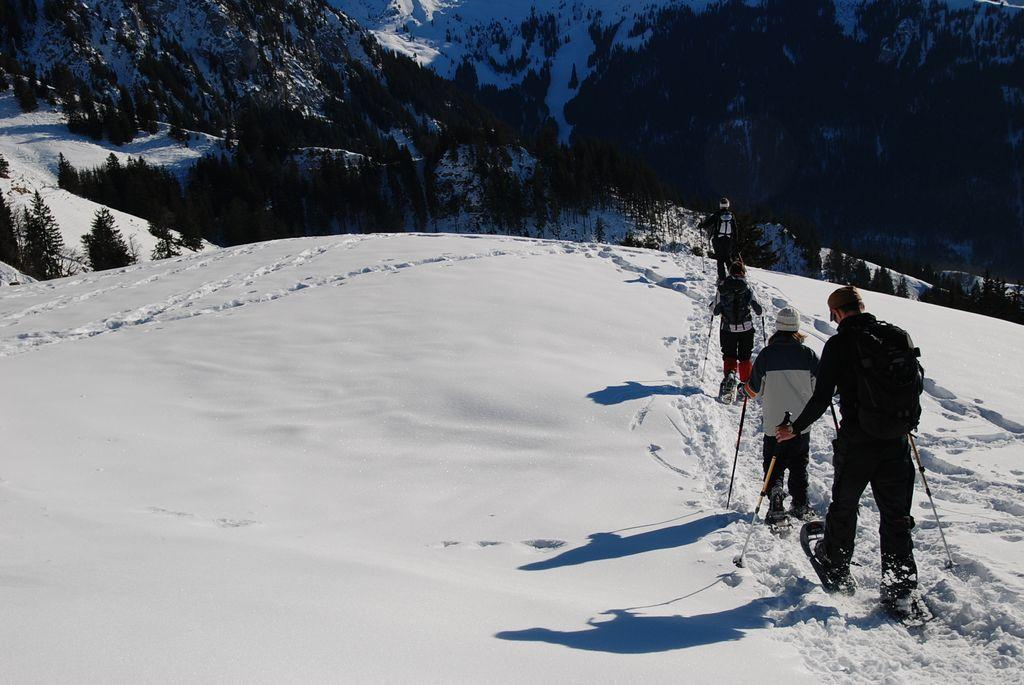What activity are the persons in the image engaged in? The persons in the image are skiing. What surface are they skiing on? They are skiing on snow. Is there snow visible on the ground in the image? Yes, there is snow on the ground in the image. What can be seen in the background of the image? There are trees in the background of the image. What type of glove is the person skiing on their back in the image? There is no glove visible on anyone's back in the image. 